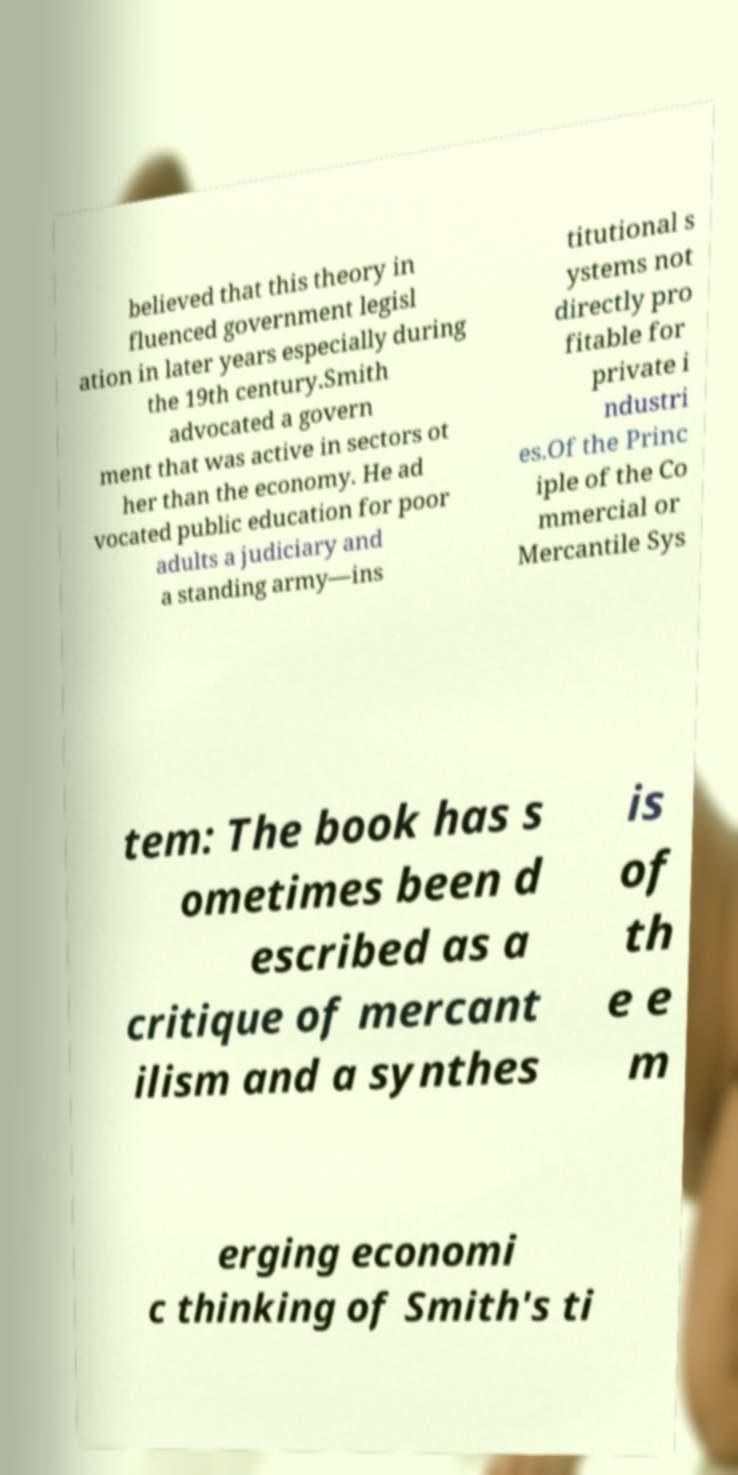Can you read and provide the text displayed in the image?This photo seems to have some interesting text. Can you extract and type it out for me? believed that this theory in fluenced government legisl ation in later years especially during the 19th century.Smith advocated a govern ment that was active in sectors ot her than the economy. He ad vocated public education for poor adults a judiciary and a standing army—ins titutional s ystems not directly pro fitable for private i ndustri es.Of the Princ iple of the Co mmercial or Mercantile Sys tem: The book has s ometimes been d escribed as a critique of mercant ilism and a synthes is of th e e m erging economi c thinking of Smith's ti 